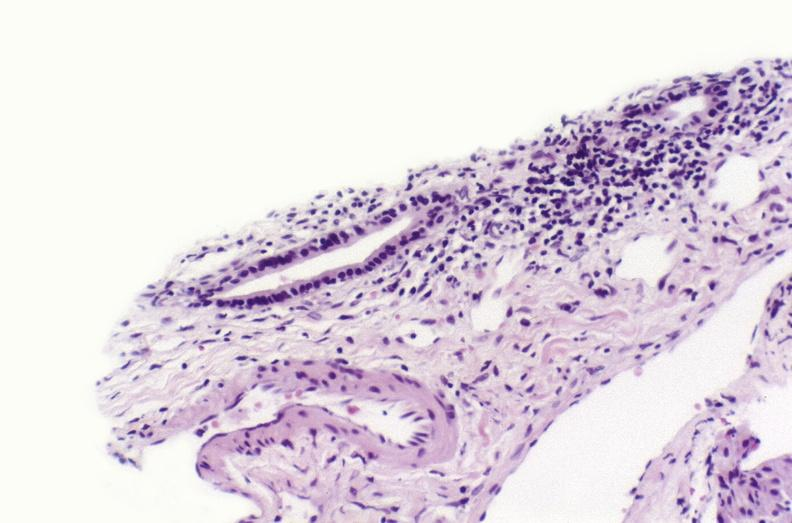what is present?
Answer the question using a single word or phrase. Hepatobiliary 